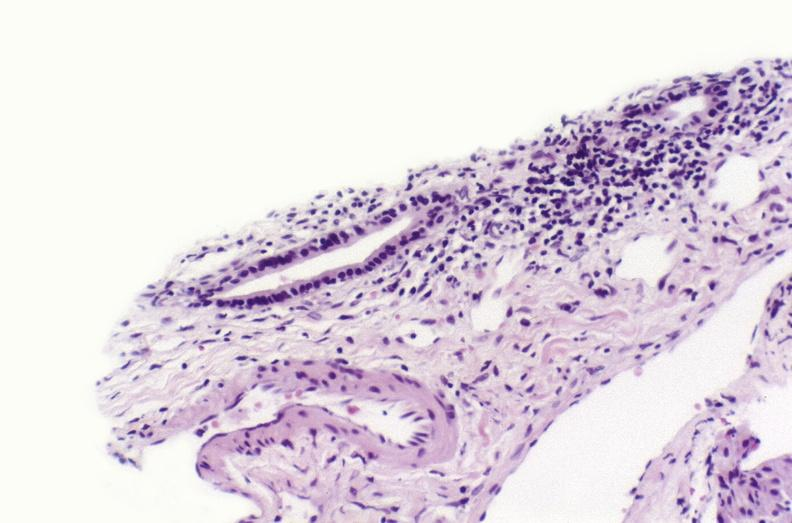what is present?
Answer the question using a single word or phrase. Hepatobiliary 